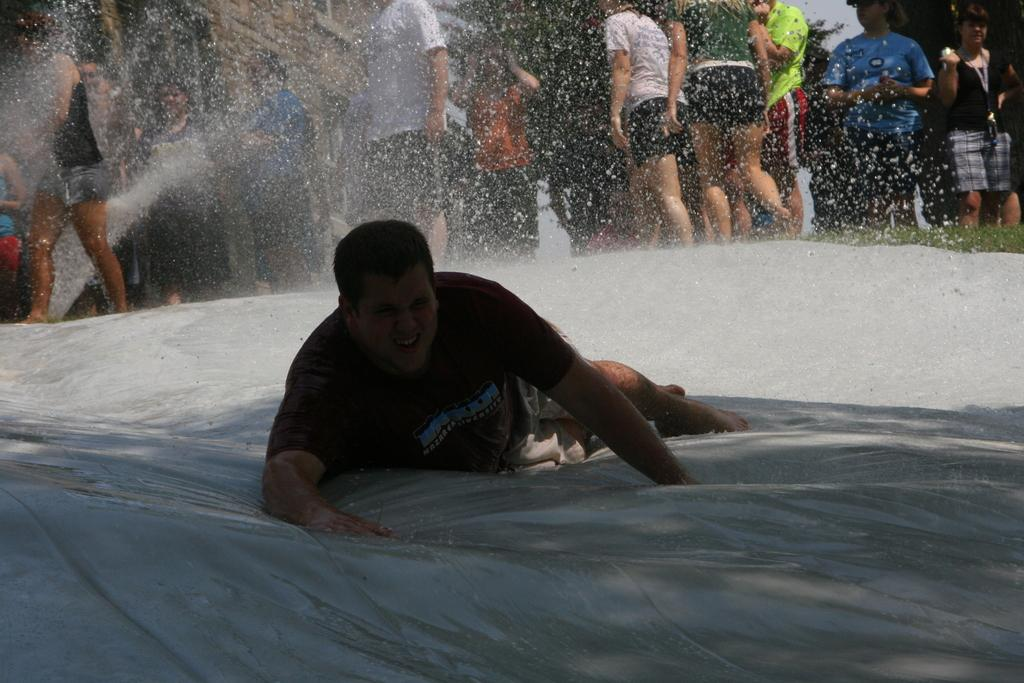Who is the main subject in the image? There is a man in the image. What is the man doing in the image? The man is falling on a white surface. Can you describe the white surface? The white surface is on a path. What can be seen in the background of the image? There are people standing and playing in the water in the background of the image. What type of jewel is the man wearing on his partner's hand in the image? There is no partner or jewel present in the image; it only features a man falling on a white surface and people in the background. 